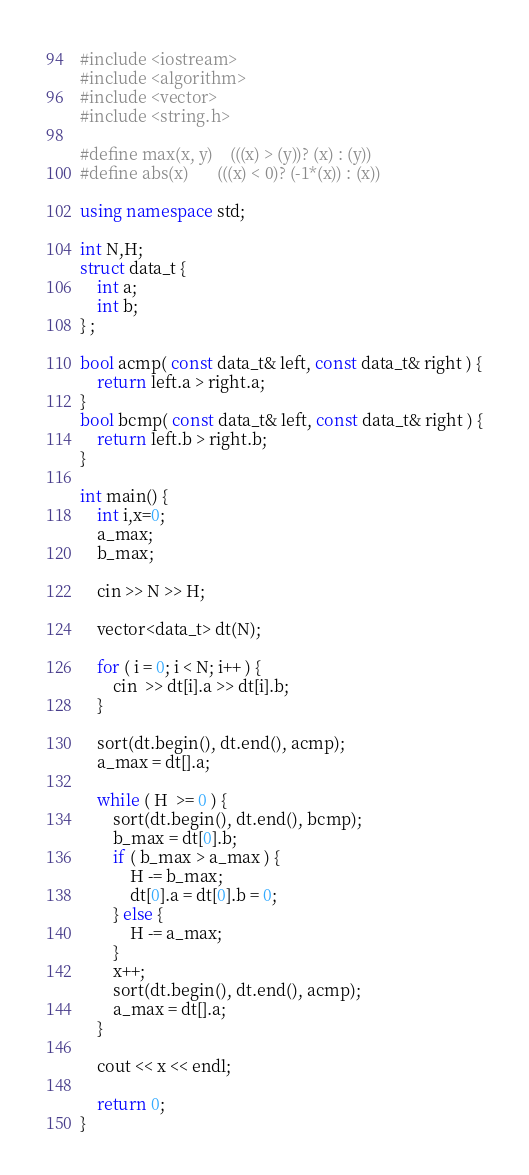<code> <loc_0><loc_0><loc_500><loc_500><_C++_>#include <iostream>
#include <algorithm>
#include <vector>
#include <string.h>

#define max(x, y)	(((x) > (y))? (x) : (y))
#define abs(x)		(((x) < 0)? (-1*(x)) : (x))

using namespace std;

int N,H;
struct data_t {
    int a;
    int b;
} ;

bool acmp( const data_t& left, const data_t& right ) {
    return left.a > right.a;
}
bool bcmp( const data_t& left, const data_t& right ) {
    return left.b > right.b;
}

int main() {
	int i,x=0;
	a_max;
	b_max;
	
	cin >> N >> H;

	vector<data_t> dt(N);

	for ( i = 0; i < N; i++ ) {
		cin  >> dt[i].a >> dt[i].b; 
	}
	
	sort(dt.begin(), dt.end(), acmp);
	a_max = dt[].a;
	
	while ( H  >= 0 ) {		
		sort(dt.begin(), dt.end(), bcmp);
		b_max = dt[0].b;
		if ( b_max > a_max ) {
			H -= b_max;
			dt[0].a = dt[0].b = 0;
		} else {
			H -= a_max;
		}
		x++;
		sort(dt.begin(), dt.end(), acmp);
		a_max = dt[].a;
	}
	
	cout << x << endl;

	return 0;
}
</code> 